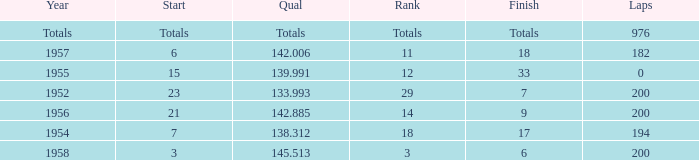Write the full table. {'header': ['Year', 'Start', 'Qual', 'Rank', 'Finish', 'Laps'], 'rows': [['Totals', 'Totals', 'Totals', 'Totals', 'Totals', '976'], ['1957', '6', '142.006', '11', '18', '182'], ['1955', '15', '139.991', '12', '33', '0'], ['1952', '23', '133.993', '29', '7', '200'], ['1956', '21', '142.885', '14', '9', '200'], ['1954', '7', '138.312', '18', '17', '194'], ['1958', '3', '145.513', '3', '6', '200']]} What place did Jimmy Reece start from when he ranked 12? 15.0. 